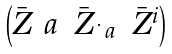<formula> <loc_0><loc_0><loc_500><loc_500>\begin{pmatrix} \bar { Z } ^ { \ } a & \bar { Z } _ { \dot { \ } a } & \bar { Z } ^ { i } \end{pmatrix}</formula> 